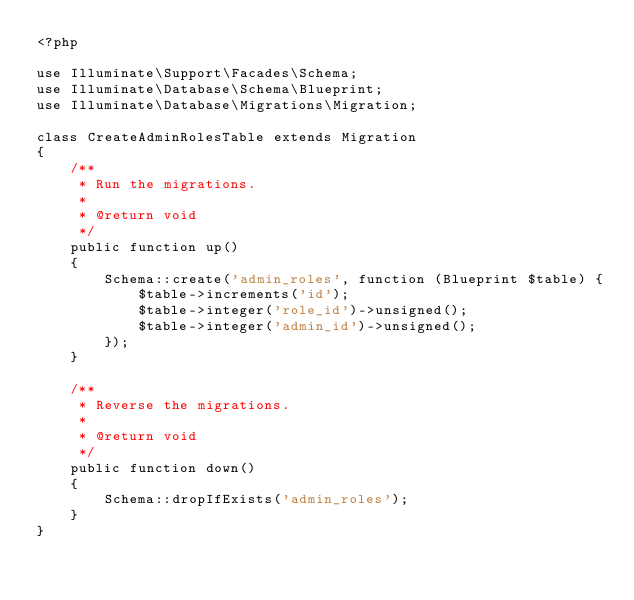Convert code to text. <code><loc_0><loc_0><loc_500><loc_500><_PHP_><?php

use Illuminate\Support\Facades\Schema;
use Illuminate\Database\Schema\Blueprint;
use Illuminate\Database\Migrations\Migration;

class CreateAdminRolesTable extends Migration
{
    /**
     * Run the migrations.
     *
     * @return void
     */
    public function up()
    {
        Schema::create('admin_roles', function (Blueprint $table) {
            $table->increments('id');
            $table->integer('role_id')->unsigned();
            $table->integer('admin_id')->unsigned();
        });
    }

    /**
     * Reverse the migrations.
     *
     * @return void
     */
    public function down()
    {
        Schema::dropIfExists('admin_roles');
    }
}
</code> 